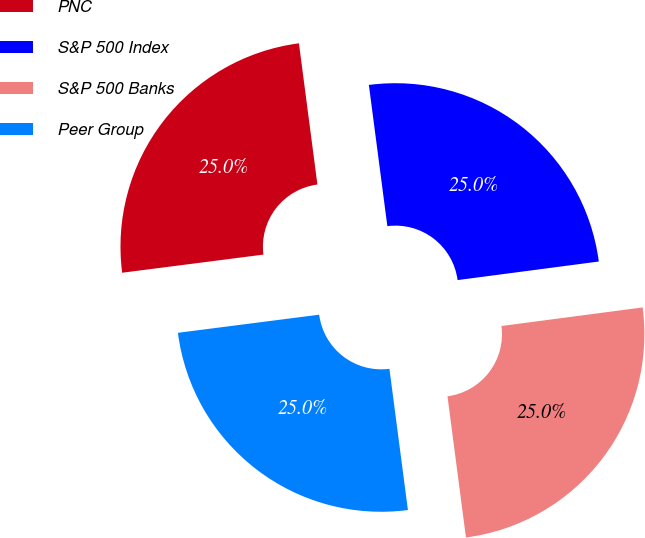<chart> <loc_0><loc_0><loc_500><loc_500><pie_chart><fcel>PNC<fcel>S&P 500 Index<fcel>S&P 500 Banks<fcel>Peer Group<nl><fcel>24.96%<fcel>24.99%<fcel>25.01%<fcel>25.04%<nl></chart> 